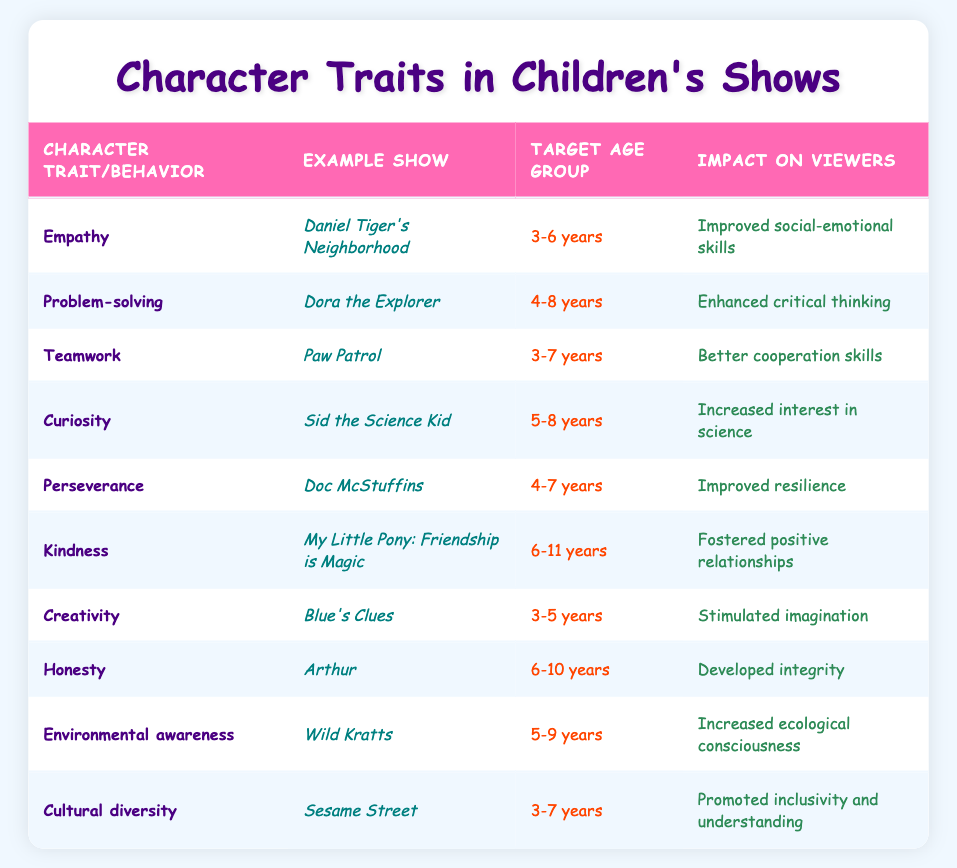What character trait does "Daniel Tiger's Neighborhood" feature? The table shows that the character trait featured in "Daniel Tiger's Neighborhood" is empathy.
Answer: Empathy Which example show targets children aged 4-8 years? The shows targeted at the age group of 4-8 years are "Dora the Explorer" and "Doc McStuffins."
Answer: Dora the Explorer, Doc McStuffins How many shows are listed that promote environmental awareness? From the table, only one show, "Wild Kratts," focuses on environmental awareness.
Answer: 1 What positive impact do shows focusing on creativity have on viewers? The table indicates that shows featuring creativity, such as "Blue's Clues," stimulate imagination among viewers.
Answer: Stimulated imagination Which character trait listed in the table is associated with the show "My Little Pony: Friendship is Magic"? The table specifies that "My Little Pony: Friendship is Magic" is associated with the character trait of kindness.
Answer: Kindness Are there any shows in the table that promote cultural diversity? Yes, "Sesame Street" is identified in the table as a show that promotes cultural diversity.
Answer: Yes What is the target age group for "Paw Patrol"? According to the table, "Paw Patrol" targets children aged 3-7 years.
Answer: 3-7 years How many shows listed focus on resilience and perseverance? The table specifies one show, "Doc McStuffins," that focuses on perseverance and emphasizes improved resilience.
Answer: 1 Do all shows in the table address the same age group? No, the target age groups vary across the shows listed in the table.
Answer: No 